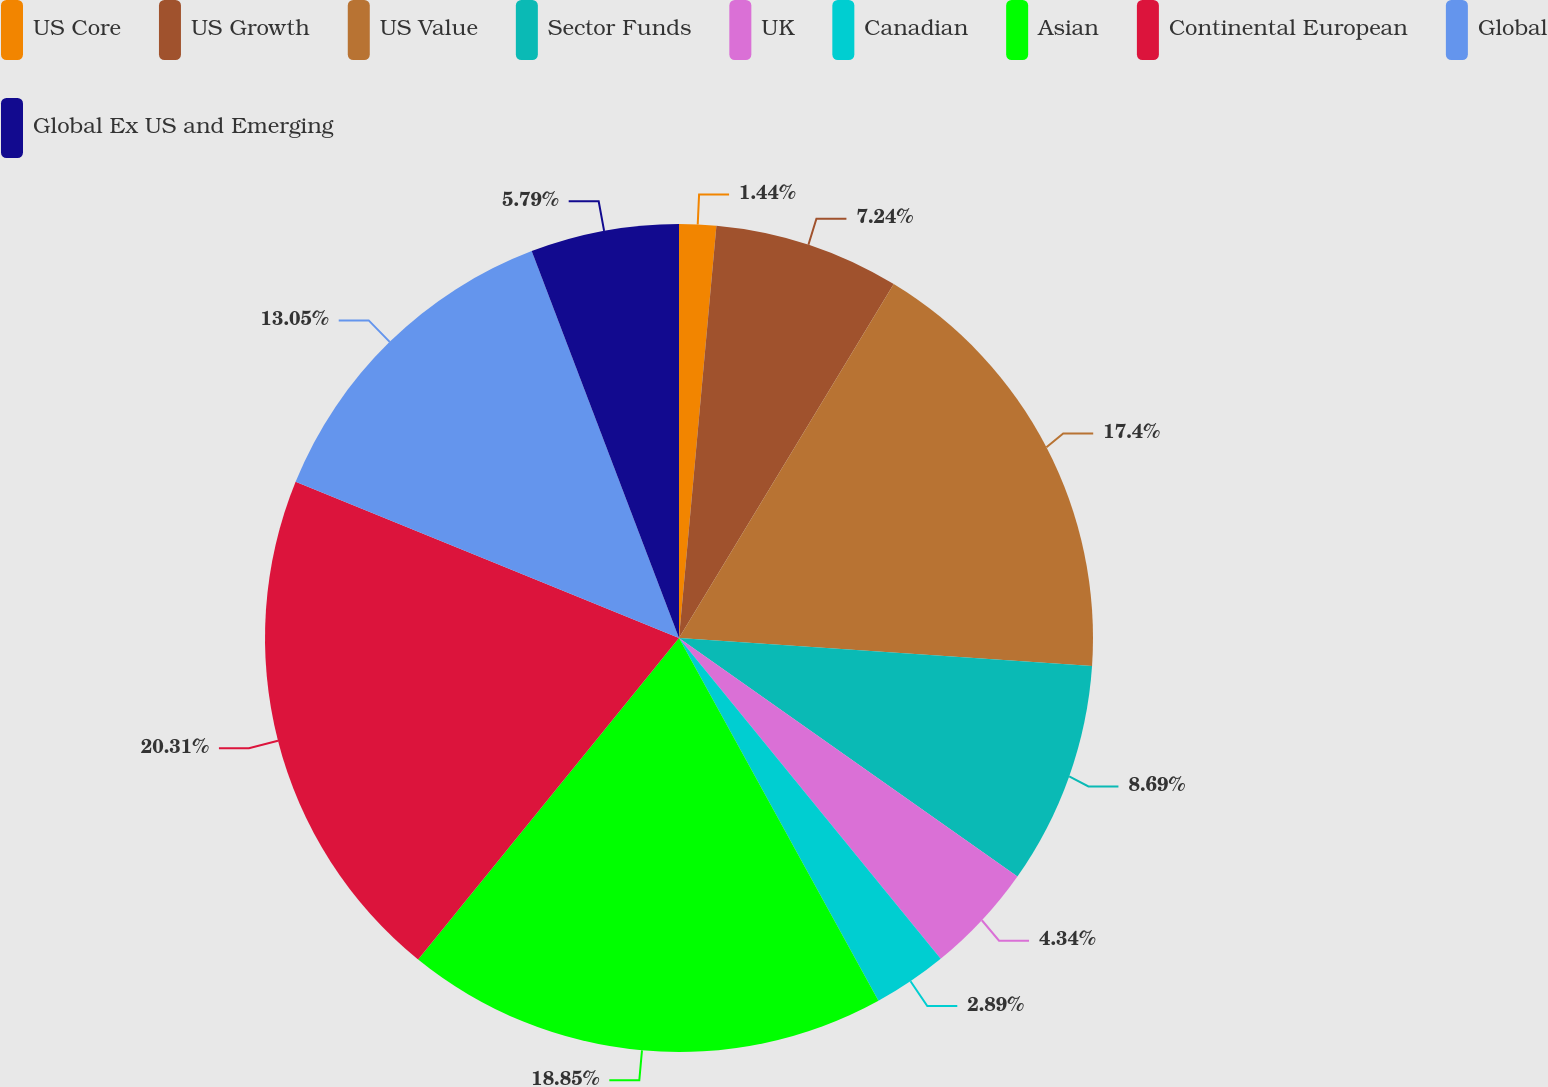<chart> <loc_0><loc_0><loc_500><loc_500><pie_chart><fcel>US Core<fcel>US Growth<fcel>US Value<fcel>Sector Funds<fcel>UK<fcel>Canadian<fcel>Asian<fcel>Continental European<fcel>Global<fcel>Global Ex US and Emerging<nl><fcel>1.44%<fcel>7.24%<fcel>17.4%<fcel>8.69%<fcel>4.34%<fcel>2.89%<fcel>18.85%<fcel>20.31%<fcel>13.05%<fcel>5.79%<nl></chart> 